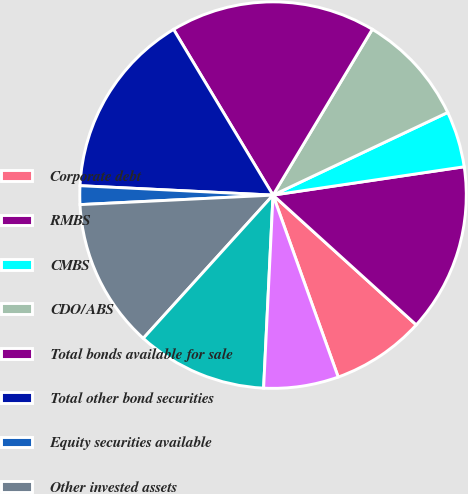Convert chart. <chart><loc_0><loc_0><loc_500><loc_500><pie_chart><fcel>Corporate debt<fcel>RMBS<fcel>CMBS<fcel>CDO/ABS<fcel>Total bonds available for sale<fcel>Total other bond securities<fcel>Equity securities available<fcel>Other invested assets<fcel>Derivative liabilities net<fcel>Total liabilities<nl><fcel>7.81%<fcel>14.06%<fcel>4.69%<fcel>9.38%<fcel>17.19%<fcel>15.62%<fcel>1.56%<fcel>12.5%<fcel>10.94%<fcel>6.25%<nl></chart> 